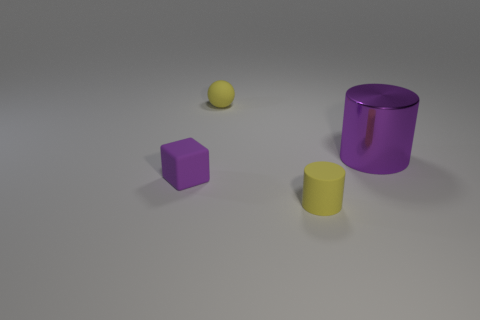Are the yellow object to the left of the small cylinder and the cube made of the same material?
Your response must be concise. Yes. There is a thing that is both on the left side of the tiny yellow matte cylinder and in front of the big metallic thing; what color is it?
Keep it short and to the point. Purple. What number of small yellow balls are on the right side of the purple object on the left side of the metallic thing?
Keep it short and to the point. 1. There is another object that is the same shape as the large metallic object; what is its material?
Ensure brevity in your answer.  Rubber. What is the color of the big cylinder?
Give a very brief answer. Purple. What number of objects are either spheres or yellow cylinders?
Ensure brevity in your answer.  2. There is a yellow object on the left side of the yellow matte cylinder in front of the tiny yellow rubber ball; what is its shape?
Your answer should be very brief. Sphere. How many other things are made of the same material as the large cylinder?
Provide a short and direct response. 0. Do the yellow cylinder and the purple thing on the left side of the big purple object have the same material?
Your answer should be very brief. Yes. How many things are yellow balls that are on the left side of the large metallic cylinder or objects that are in front of the tiny matte sphere?
Provide a short and direct response. 4. 